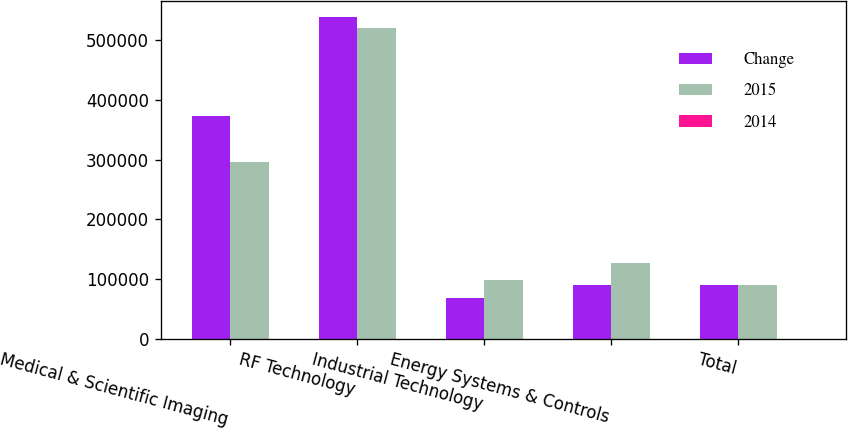Convert chart. <chart><loc_0><loc_0><loc_500><loc_500><stacked_bar_chart><ecel><fcel>Medical & Scientific Imaging<fcel>RF Technology<fcel>Industrial Technology<fcel>Energy Systems & Controls<fcel>Total<nl><fcel>Change<fcel>373213<fcel>538877<fcel>68002<fcel>90365<fcel>90365<nl><fcel>2015<fcel>296098<fcel>520727<fcel>97507<fcel>126838<fcel>90365<nl><fcel>2014<fcel>26<fcel>3.5<fcel>30.3<fcel>28.8<fcel>2.8<nl></chart> 